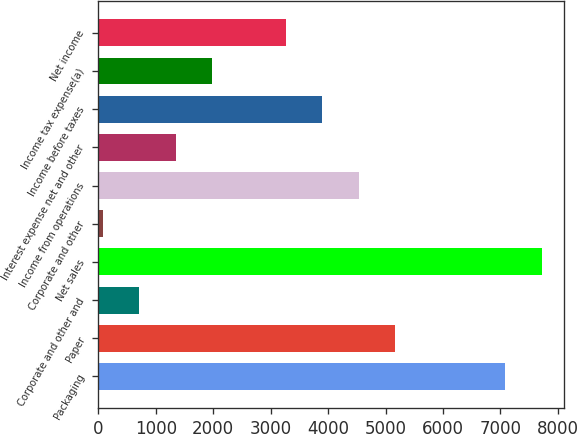<chart> <loc_0><loc_0><loc_500><loc_500><bar_chart><fcel>Packaging<fcel>Paper<fcel>Corporate and other and<fcel>Net sales<fcel>Corporate and other<fcel>Income from operations<fcel>Interest expense net and other<fcel>Income before taxes<fcel>Income tax expense(a)<fcel>Net income<nl><fcel>7082.21<fcel>5170.28<fcel>709.11<fcel>7719.52<fcel>71.8<fcel>4532.97<fcel>1346.42<fcel>3895.66<fcel>1983.73<fcel>3258.35<nl></chart> 